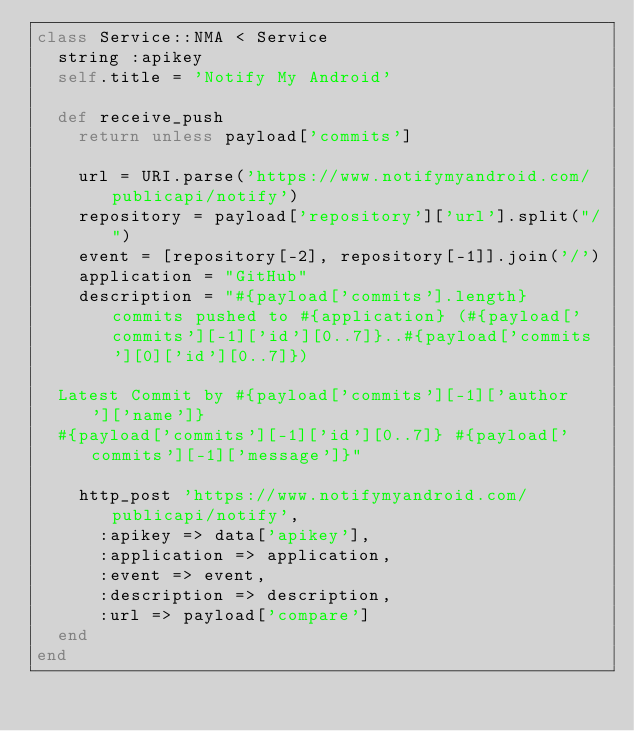<code> <loc_0><loc_0><loc_500><loc_500><_Ruby_>class Service::NMA < Service
  string :apikey
  self.title = 'Notify My Android'

  def receive_push
    return unless payload['commits']
    
    url = URI.parse('https://www.notifymyandroid.com/publicapi/notify')
    repository = payload['repository']['url'].split("/")
    event = [repository[-2], repository[-1]].join('/')
    application = "GitHub"
    description = "#{payload['commits'].length} commits pushed to #{application} (#{payload['commits'][-1]['id'][0..7]}..#{payload['commits'][0]['id'][0..7]})
    
  Latest Commit by #{payload['commits'][-1]['author']['name']}
  #{payload['commits'][-1]['id'][0..7]} #{payload['commits'][-1]['message']}"

    http_post 'https://www.notifymyandroid.com/publicapi/notify',
      :apikey => data['apikey'],
      :application => application,
      :event => event,
      :description => description,
      :url => payload['compare']
  end
end
</code> 